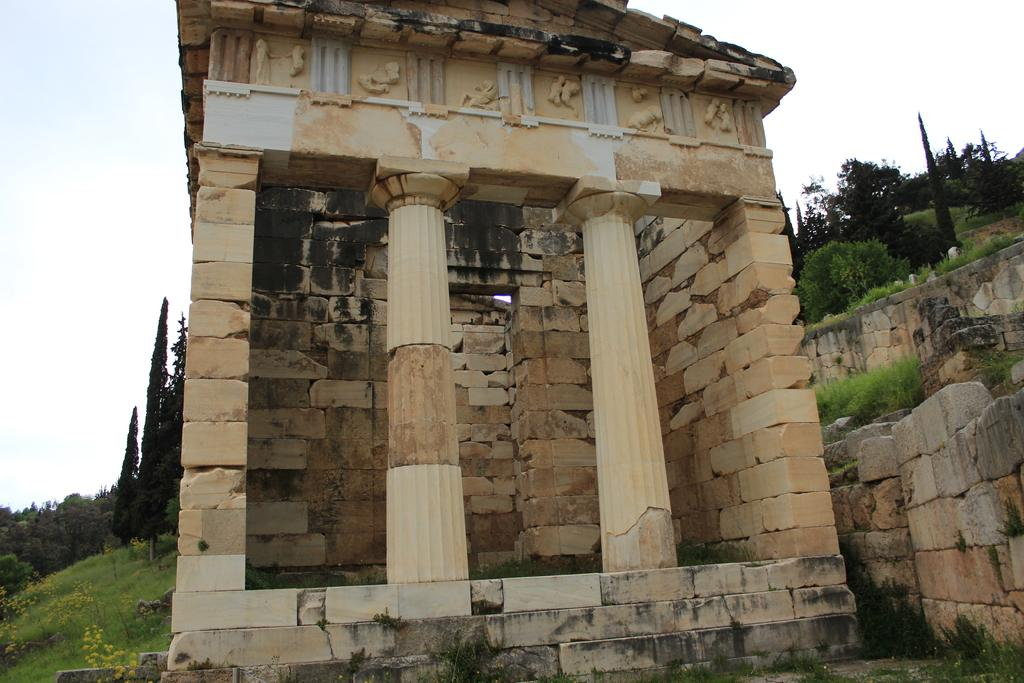What type of structure is present in the image? There is a building in the image. What is the appearance of the wall in the image? There is a wall visible in the image. What type of vegetation can be seen in the image? There are many trees in the image. What can be seen in the background of the image? The sky is visible in the background of the image. Who is the owner of the mailbox in the image? There is no mailbox present in the image. 